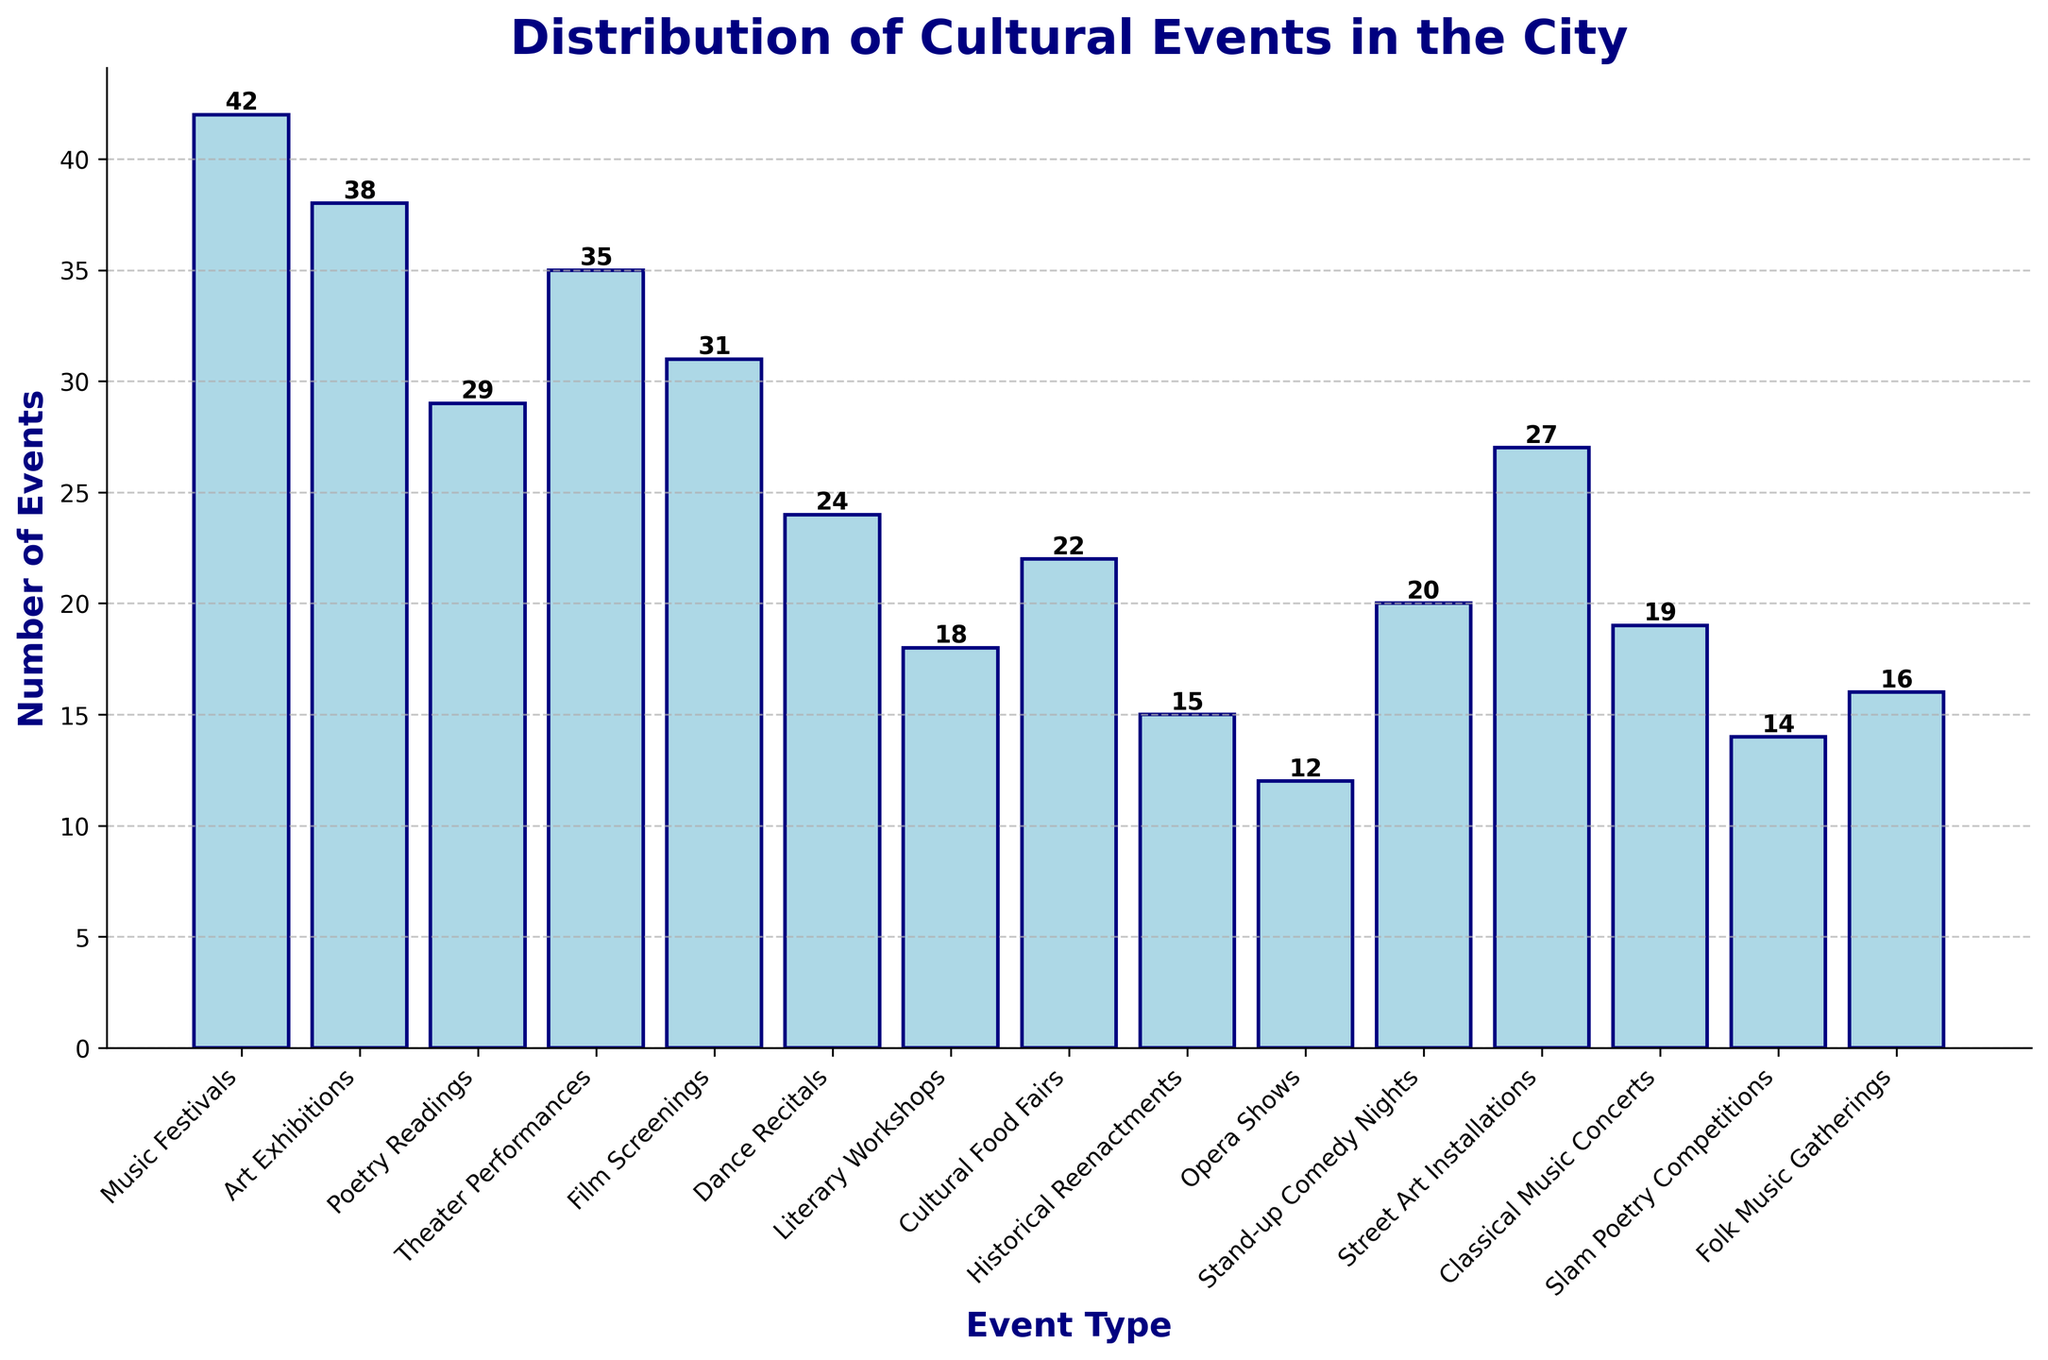What is the most common type of cultural event? The most common type of cultural event can be identified by the highest bar on the chart. The highest bar corresponds to "Music Festivals" with 42 events.
Answer: Music Festivals Which event type has exactly 14 occurrences? We need to look at the labels on the bars and find the one with a height of 14. "Slam Poetry Competitions" has 14 occurrences.
Answer: Slam Poetry Competitions How many more Music Festivals were there compared to Historical Reenactments? Look at the heights of the bars for both "Music Festivals" and "Historical Reenactments". Music Festivals have 42 events and Historical Reenactments have 15. The difference is 42 - 15 = 27.
Answer: 27 What is the total number of "Poetry Readings" and "Slam Poetry Competitions"? Add the numbers of events for "Poetry Readings" and "Slam Poetry Competitions". Poetry Readings have 29 events and Slam Poetry Competitions have 14 events. Total is 29 + 14 = 43.
Answer: 43 Is the number of Theater Performances greater than Film Screenings? Compare the heights of the bars for "Theater Performances" and "Film Screenings". Theater Performances have 35 events, and Film Screenings have 31 events, so the former is greater.
Answer: Yes Which event type has the least number of occurrences? The bar with the smallest height represents the least frequent event. "Opera Shows" have the least number with 12 events.
Answer: Opera Shows What is the difference in the number of events between the most and least frequent event types? Calculate the difference between the heights of the highest and lowest bars. The highest is "Music Festivals" with 42, and the lowest is "Opera Shows" with 12. The difference is 42 - 12 = 30.
Answer: 30 What is the total number of events for the three least frequent event types? Identify the three smallest bars. They are "Opera Shows" (12), "Historical Reenactments" (15), and "Slam Poetry Competitions" (14). Sum them up: 12 + 15 + 14 = 41.
Answer: 41 Which event type has fewer occurrences than Dance Recitals but more than Stand-up Comedy Nights? Compare the heights of relevant bars. Dance Recitals have 24 events and Stand-up Comedy Nights have 20 events. The bar representing "Cultural Food Fairs" has 22 events, which fits between 24 and 20.
Answer: Cultural Food Fairs Which event type has the closest number of occurrences to Classical Music Concerts? Identify the bar height of "Classical Music Concerts" (19) and compare with nearby values. "Literary Workshops" with 18 events,  is very close to 19.
Answer: Literary Workshops 